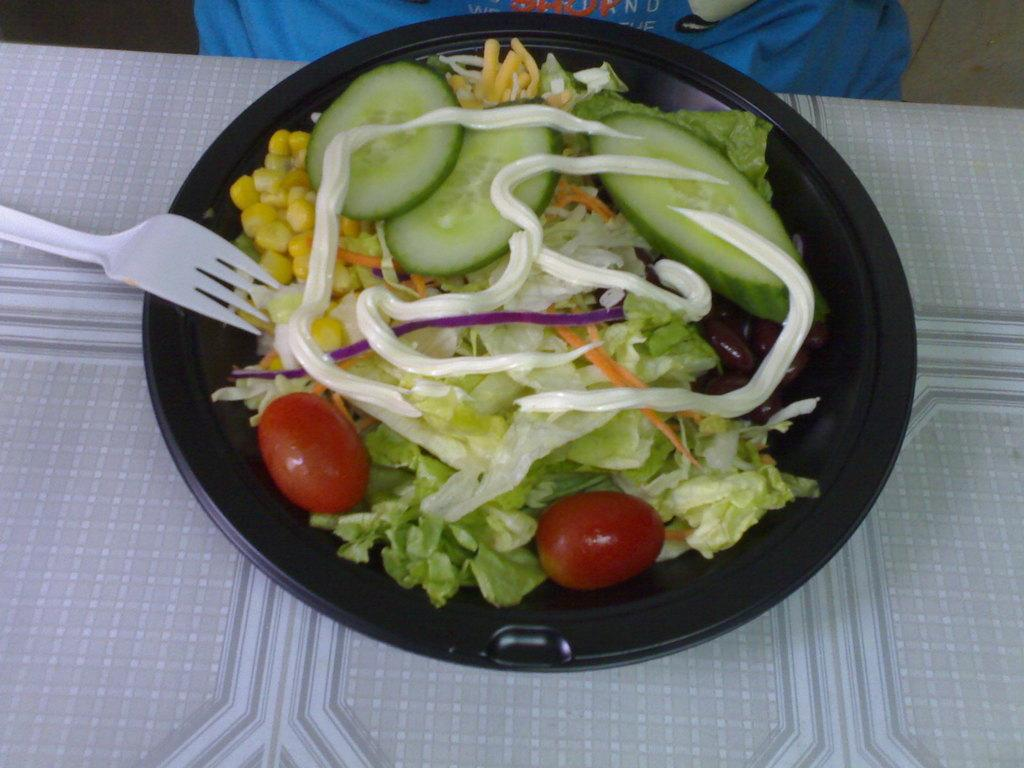What type of food can be seen in the image? There is food in the image, but the specific type is not mentioned. What utensil is present in the image? There is a fork in the image. What color is the bowl containing the food and fork? The bowl is black. What is the bowl placed on? The black bowl is placed on a cloth. What color is the cloth at the top of the image? The cloth at the top of the image is blue. What type of jar can be seen in the image? There is no jar present in the image. What type of bushes are visible in the image? There are no bushes visible in the image. 